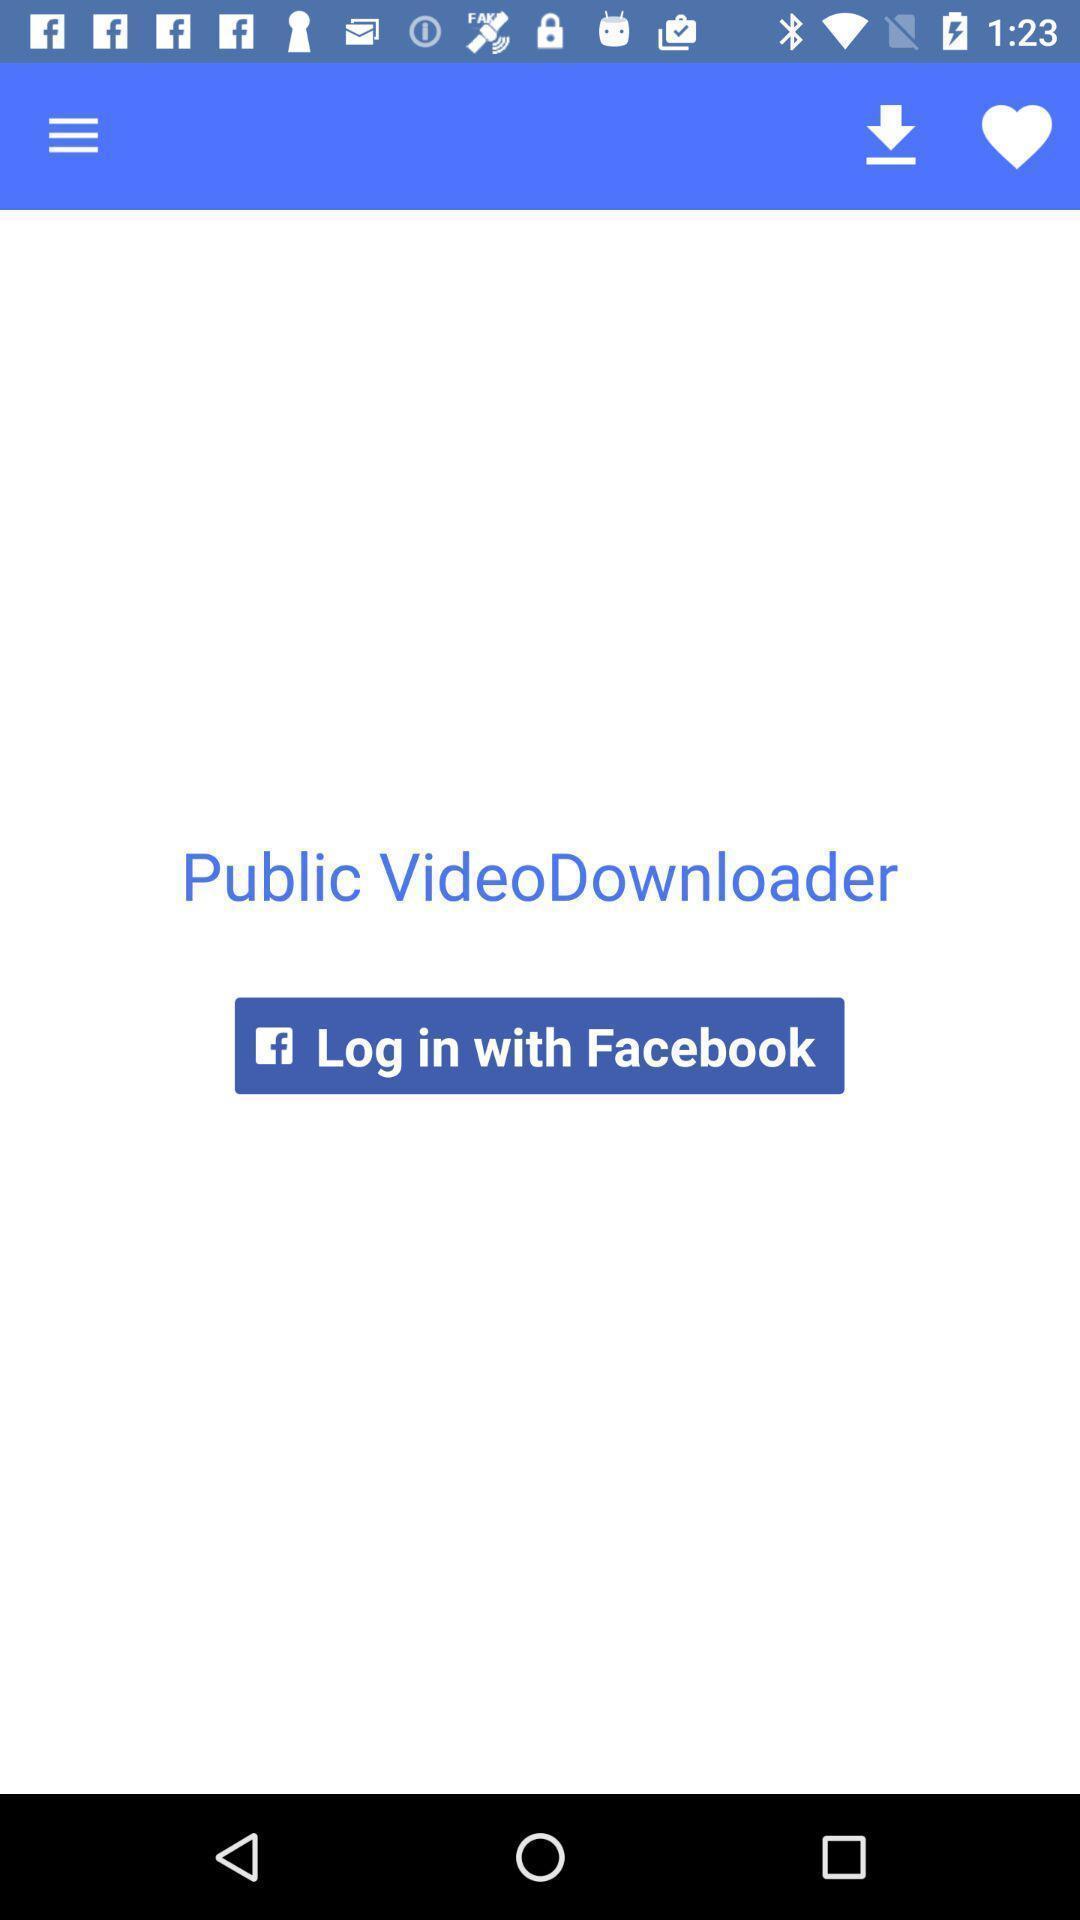Summarize the main components in this picture. Page displaying to login for an application. 